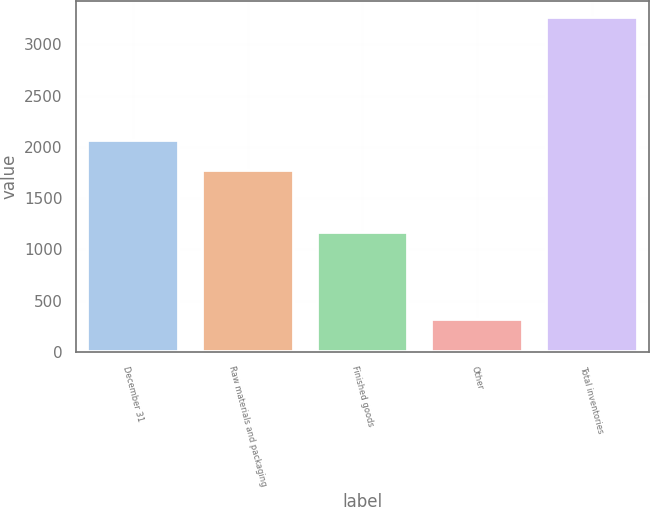<chart> <loc_0><loc_0><loc_500><loc_500><bar_chart><fcel>December 31<fcel>Raw materials and packaging<fcel>Finished goods<fcel>Other<fcel>Total inventories<nl><fcel>2067.4<fcel>1773<fcel>1171<fcel>320<fcel>3264<nl></chart> 